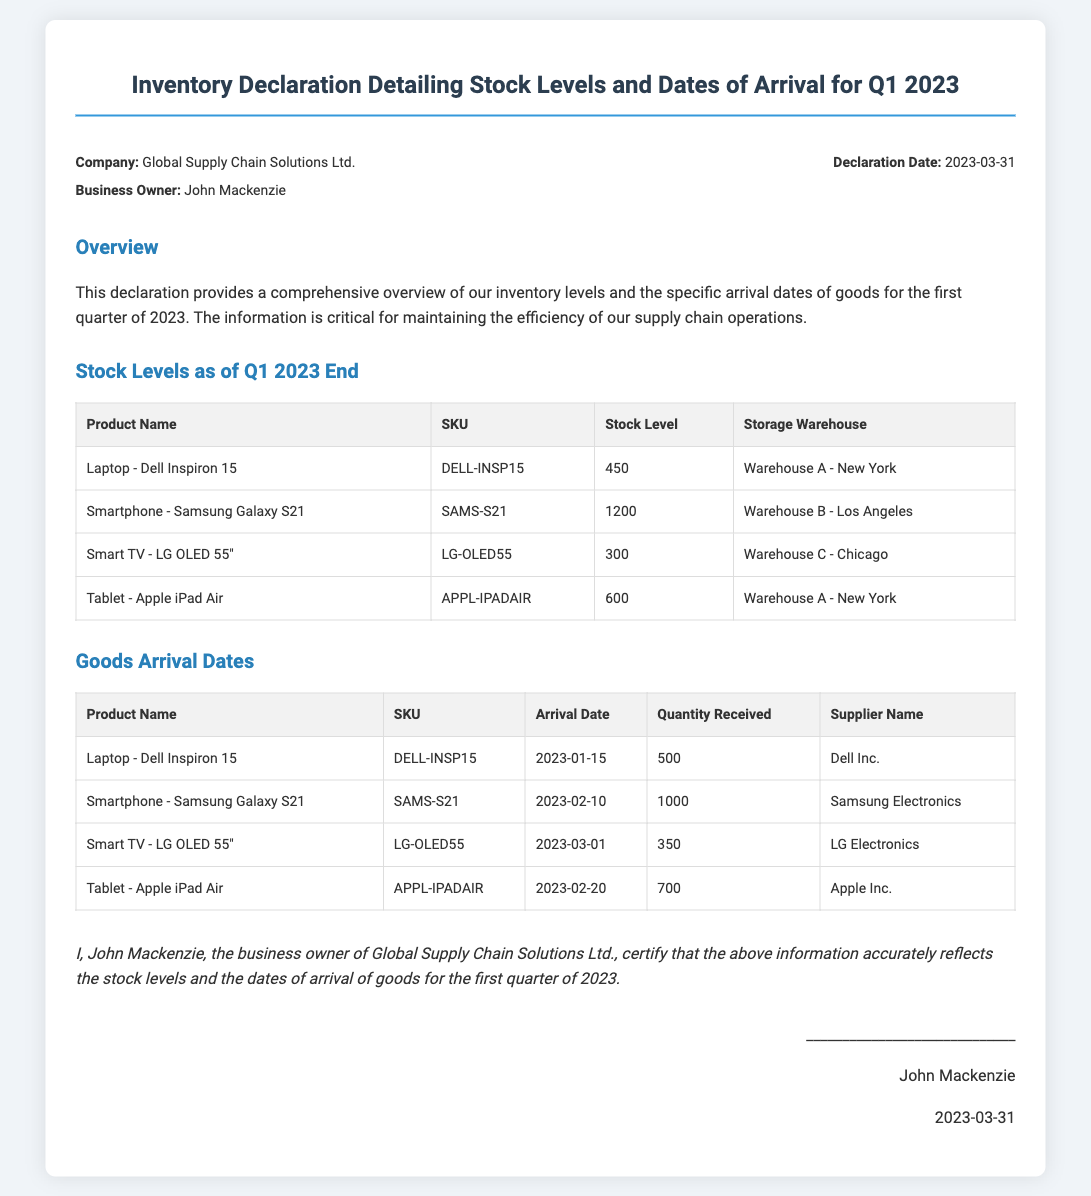What is the company name? The company name is stated at the beginning of the document as Global Supply Chain Solutions Ltd.
Answer: Global Supply Chain Solutions Ltd Who is the business owner? The business owner's name is mentioned in the header section of the document as John Mackenzie.
Answer: John Mackenzie What is the declaration date? The declaration date is explicitly provided near the top of the document as 2023-03-31.
Answer: 2023-03-31 How many units of the Laptop - Dell Inspiron 15 were received? The quantity received for the Laptop - Dell Inspiron 15 is detailed in the Goods Arrival section as 500.
Answer: 500 What is the stock level of the Smartphone - Samsung Galaxy S21? The stock level of the Smartphone - Samsung Galaxy S21 is provided in the Stock Levels table as 1200.
Answer: 1200 Which product has the earliest arrival date? The product with the earliest arrival date is indicated in the Goods Arrival section, which shows the Laptop - Dell Inspiron 15 with a date of 2023-01-15.
Answer: Laptop - Dell Inspiron 15 What warehouse holds the Smart TV - LG OLED 55"? The Smart TV - LG OLED 55" is stored in the inventory at Warehouse C - Chicago, as listed in the Stock Levels table.
Answer: Warehouse C - Chicago How many different products are listed in the stock levels? The total number of different products listed in the Stock Levels section is counted from the table, resulting in four products.
Answer: 4 Who certified the information in this declaration? The declaration is certified by John Mackenzie, whose name appears at the end of the document.
Answer: John Mackenzie 